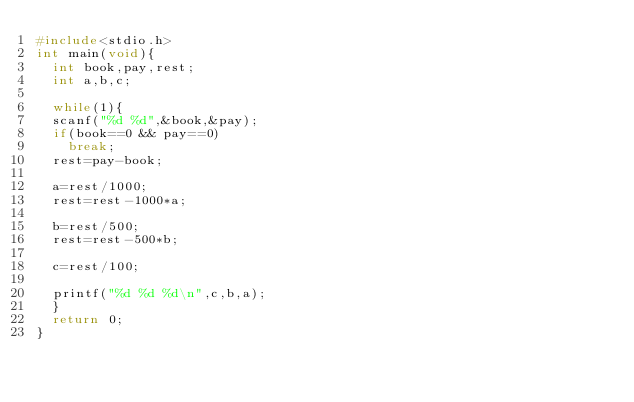<code> <loc_0><loc_0><loc_500><loc_500><_C_>#include<stdio.h>
int main(void){
  int book,pay,rest;
  int a,b,c;
  
  while(1){
  scanf("%d %d",&book,&pay);
  if(book==0 && pay==0)
    break;
  rest=pay-book;
  
  a=rest/1000;
  rest=rest-1000*a;

  b=rest/500;
  rest=rest-500*b;

  c=rest/100;
  
  printf("%d %d %d\n",c,b,a);
  }
  return 0;
}
  
  </code> 